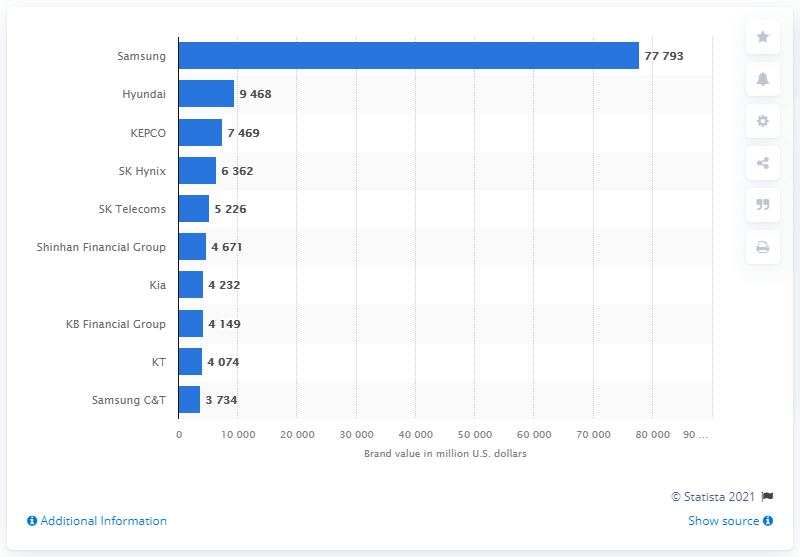Indicate a few pertinent items in this graphic. Samsung's brand value in US dollars in 2020 was approximately 77,793. 